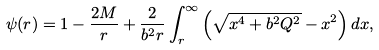<formula> <loc_0><loc_0><loc_500><loc_500>\psi ( r ) = 1 - \frac { 2 M } { r } + \frac { 2 } { b ^ { 2 } r } \int ^ { \infty } _ { r } \left ( \sqrt { x ^ { 4 } + b ^ { 2 } Q ^ { 2 } } - x ^ { 2 } \right ) d x ,</formula> 